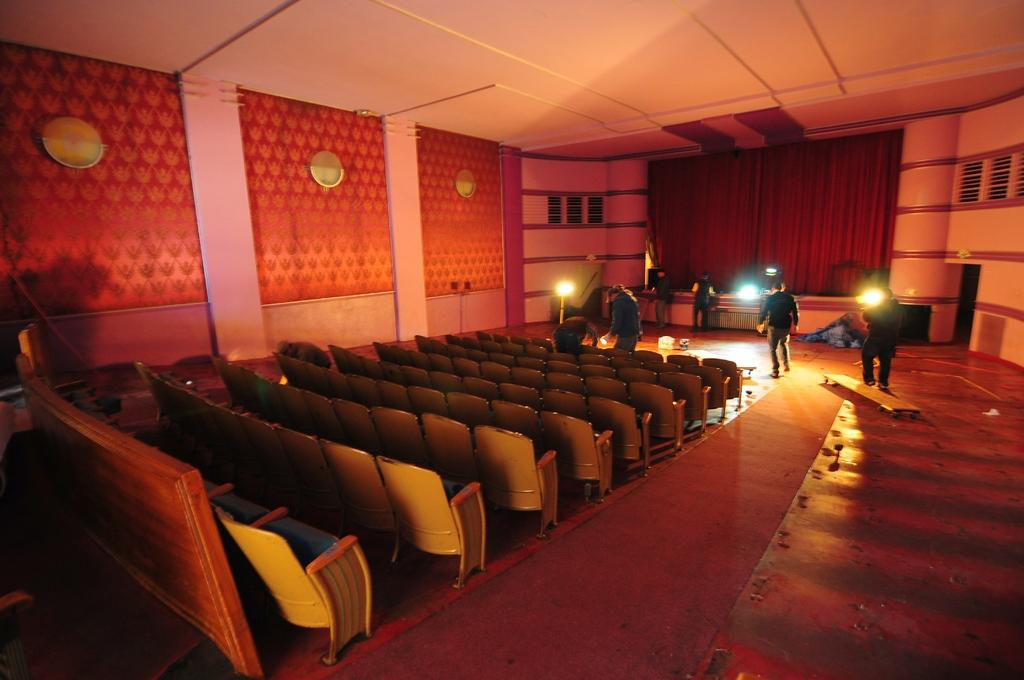What type of space is depicted in the image? There is a big hall in the image. What furniture can be seen in the hall? There are many chairs in the hall. What feature is present on one end of the hall? There is a stage in the hall. What are the people on the stage doing? People are standing on the stage. What can be seen illuminating the hall? There are lights visible in the image. Can you see a duck swimming in the hall in the image? There is no duck present in the image; it depicts a big hall with chairs, a stage, people, and lights. 